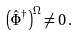<formula> <loc_0><loc_0><loc_500><loc_500>\left ( \hat { \Phi } ^ { \dagger } \right ) ^ { \Omega } \neq 0 \, .</formula> 